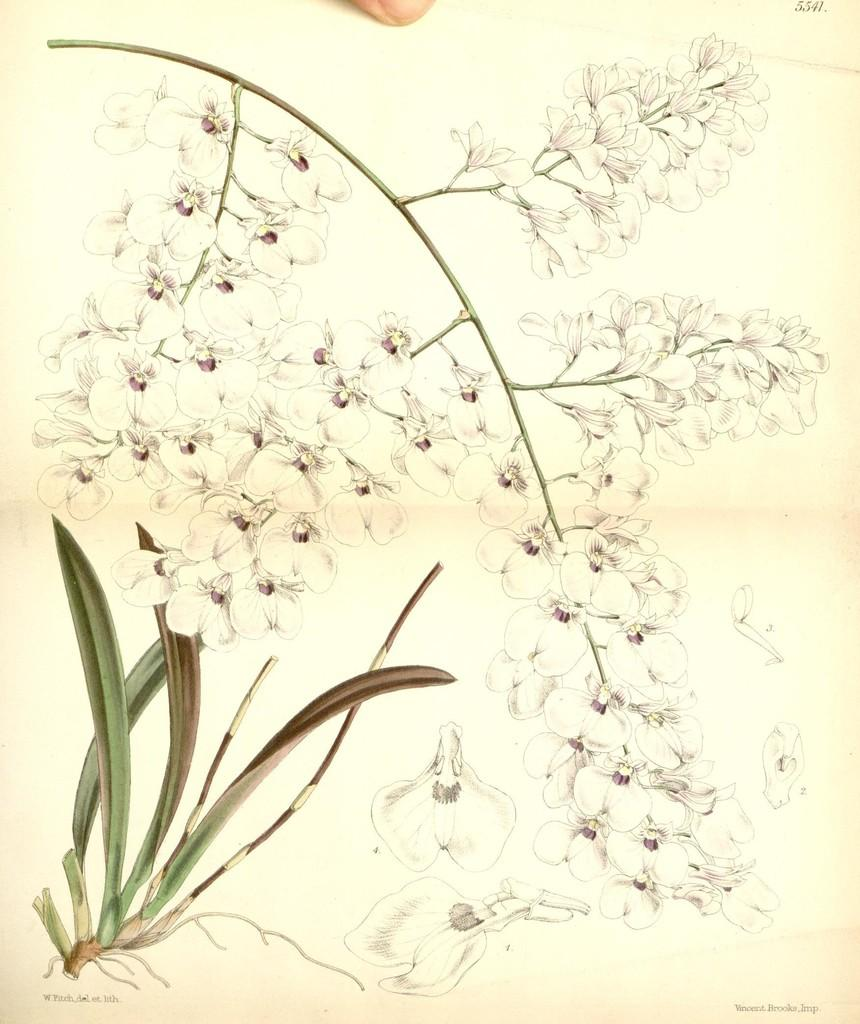What is depicted in the paintings in the image? The image contains paintings of a plant. Can you describe the main elements of the plant in the painting? There are flowers on a stem in the center of the painting. What additional detail can be seen in the painting? There is a nail on a finger at the top of the painting. What type of road can be seen in the painting? There is no road present in the painting; it features a plant with flowers on a stem and a nail on a finger. What magical properties does the plant possess in the painting? The painting does not depict any magical properties of the plant; it simply shows a plant with flowers on a stem and a nail on a finger. 